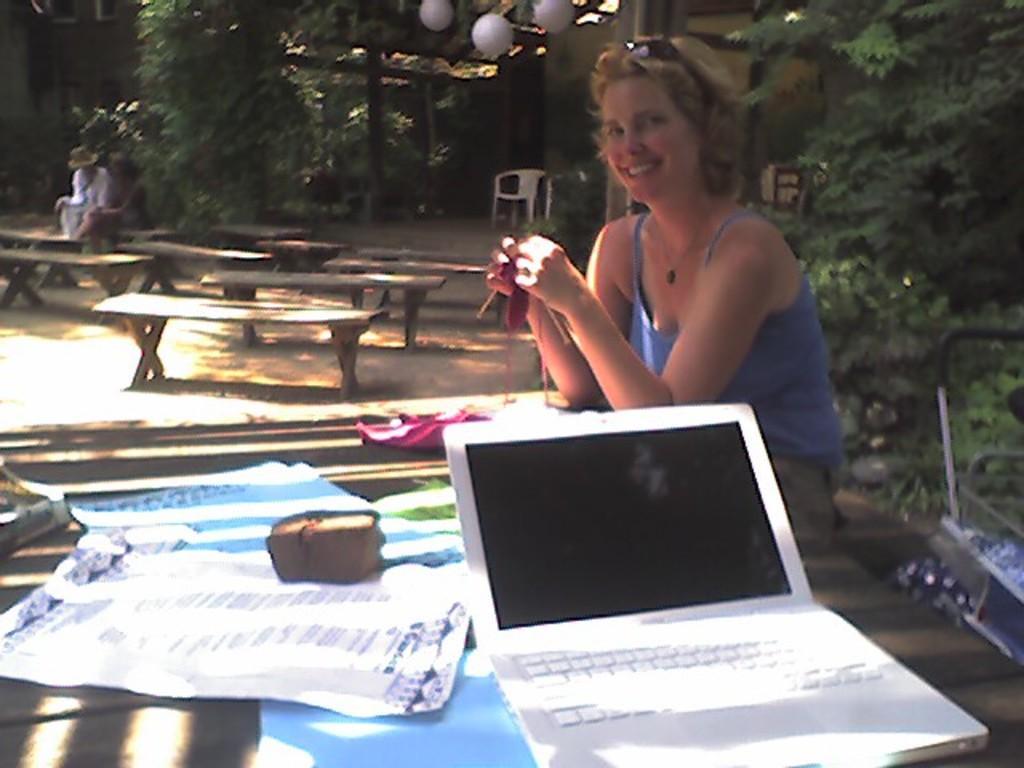Describe this image in one or two sentences. In this picture we can see a woman. She is smiling. This is table. On the table there is a laptop. Here on the background we can see some trees and these are the benches. 